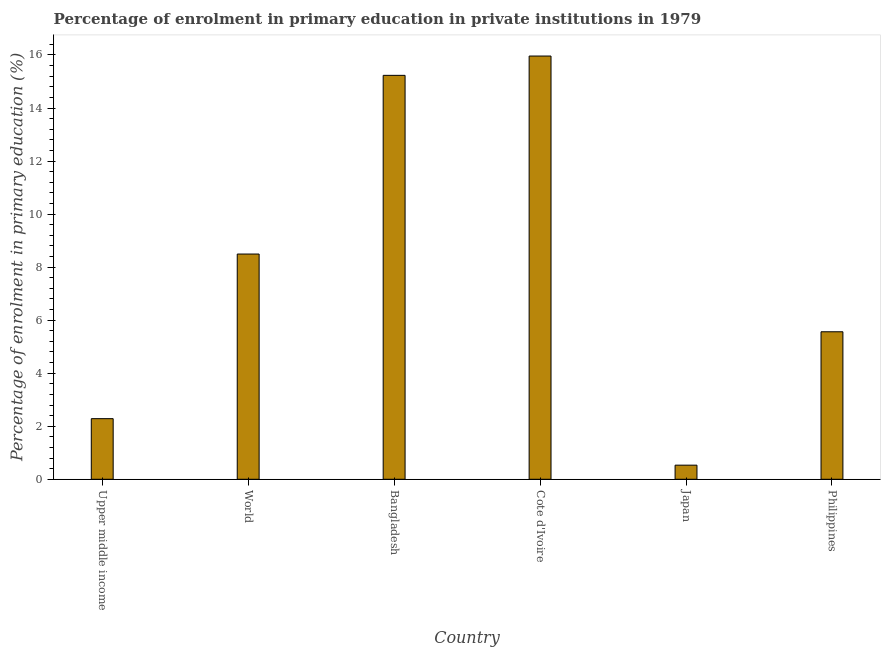Does the graph contain any zero values?
Provide a succinct answer. No. What is the title of the graph?
Give a very brief answer. Percentage of enrolment in primary education in private institutions in 1979. What is the label or title of the X-axis?
Offer a terse response. Country. What is the label or title of the Y-axis?
Provide a succinct answer. Percentage of enrolment in primary education (%). What is the enrolment percentage in primary education in World?
Your answer should be very brief. 8.49. Across all countries, what is the maximum enrolment percentage in primary education?
Provide a short and direct response. 15.96. Across all countries, what is the minimum enrolment percentage in primary education?
Offer a terse response. 0.53. In which country was the enrolment percentage in primary education maximum?
Make the answer very short. Cote d'Ivoire. What is the sum of the enrolment percentage in primary education?
Keep it short and to the point. 48.06. What is the difference between the enrolment percentage in primary education in Upper middle income and World?
Offer a terse response. -6.21. What is the average enrolment percentage in primary education per country?
Offer a very short reply. 8.01. What is the median enrolment percentage in primary education?
Your answer should be very brief. 7.03. In how many countries, is the enrolment percentage in primary education greater than 4 %?
Provide a short and direct response. 4. What is the ratio of the enrolment percentage in primary education in Bangladesh to that in Japan?
Provide a short and direct response. 28.62. Is the difference between the enrolment percentage in primary education in Bangladesh and Upper middle income greater than the difference between any two countries?
Offer a terse response. No. What is the difference between the highest and the second highest enrolment percentage in primary education?
Offer a very short reply. 0.73. Is the sum of the enrolment percentage in primary education in Japan and Upper middle income greater than the maximum enrolment percentage in primary education across all countries?
Offer a very short reply. No. What is the difference between the highest and the lowest enrolment percentage in primary education?
Your answer should be compact. 15.43. How many bars are there?
Give a very brief answer. 6. Are all the bars in the graph horizontal?
Provide a succinct answer. No. What is the difference between two consecutive major ticks on the Y-axis?
Give a very brief answer. 2. What is the Percentage of enrolment in primary education (%) of Upper middle income?
Your answer should be very brief. 2.29. What is the Percentage of enrolment in primary education (%) in World?
Provide a succinct answer. 8.49. What is the Percentage of enrolment in primary education (%) of Bangladesh?
Offer a very short reply. 15.23. What is the Percentage of enrolment in primary education (%) in Cote d'Ivoire?
Your answer should be very brief. 15.96. What is the Percentage of enrolment in primary education (%) of Japan?
Your answer should be compact. 0.53. What is the Percentage of enrolment in primary education (%) in Philippines?
Make the answer very short. 5.56. What is the difference between the Percentage of enrolment in primary education (%) in Upper middle income and World?
Make the answer very short. -6.21. What is the difference between the Percentage of enrolment in primary education (%) in Upper middle income and Bangladesh?
Offer a terse response. -12.95. What is the difference between the Percentage of enrolment in primary education (%) in Upper middle income and Cote d'Ivoire?
Offer a terse response. -13.67. What is the difference between the Percentage of enrolment in primary education (%) in Upper middle income and Japan?
Your response must be concise. 1.75. What is the difference between the Percentage of enrolment in primary education (%) in Upper middle income and Philippines?
Provide a succinct answer. -3.28. What is the difference between the Percentage of enrolment in primary education (%) in World and Bangladesh?
Provide a short and direct response. -6.74. What is the difference between the Percentage of enrolment in primary education (%) in World and Cote d'Ivoire?
Your response must be concise. -7.47. What is the difference between the Percentage of enrolment in primary education (%) in World and Japan?
Provide a short and direct response. 7.96. What is the difference between the Percentage of enrolment in primary education (%) in World and Philippines?
Your answer should be very brief. 2.93. What is the difference between the Percentage of enrolment in primary education (%) in Bangladesh and Cote d'Ivoire?
Your answer should be very brief. -0.73. What is the difference between the Percentage of enrolment in primary education (%) in Bangladesh and Japan?
Give a very brief answer. 14.7. What is the difference between the Percentage of enrolment in primary education (%) in Bangladesh and Philippines?
Your response must be concise. 9.67. What is the difference between the Percentage of enrolment in primary education (%) in Cote d'Ivoire and Japan?
Make the answer very short. 15.43. What is the difference between the Percentage of enrolment in primary education (%) in Cote d'Ivoire and Philippines?
Offer a terse response. 10.4. What is the difference between the Percentage of enrolment in primary education (%) in Japan and Philippines?
Ensure brevity in your answer.  -5.03. What is the ratio of the Percentage of enrolment in primary education (%) in Upper middle income to that in World?
Your answer should be compact. 0.27. What is the ratio of the Percentage of enrolment in primary education (%) in Upper middle income to that in Cote d'Ivoire?
Your response must be concise. 0.14. What is the ratio of the Percentage of enrolment in primary education (%) in Upper middle income to that in Japan?
Your answer should be very brief. 4.29. What is the ratio of the Percentage of enrolment in primary education (%) in Upper middle income to that in Philippines?
Keep it short and to the point. 0.41. What is the ratio of the Percentage of enrolment in primary education (%) in World to that in Bangladesh?
Your answer should be compact. 0.56. What is the ratio of the Percentage of enrolment in primary education (%) in World to that in Cote d'Ivoire?
Make the answer very short. 0.53. What is the ratio of the Percentage of enrolment in primary education (%) in World to that in Japan?
Your answer should be very brief. 15.96. What is the ratio of the Percentage of enrolment in primary education (%) in World to that in Philippines?
Give a very brief answer. 1.53. What is the ratio of the Percentage of enrolment in primary education (%) in Bangladesh to that in Cote d'Ivoire?
Provide a succinct answer. 0.95. What is the ratio of the Percentage of enrolment in primary education (%) in Bangladesh to that in Japan?
Make the answer very short. 28.62. What is the ratio of the Percentage of enrolment in primary education (%) in Bangladesh to that in Philippines?
Provide a short and direct response. 2.74. What is the ratio of the Percentage of enrolment in primary education (%) in Cote d'Ivoire to that in Japan?
Make the answer very short. 29.98. What is the ratio of the Percentage of enrolment in primary education (%) in Cote d'Ivoire to that in Philippines?
Give a very brief answer. 2.87. What is the ratio of the Percentage of enrolment in primary education (%) in Japan to that in Philippines?
Your answer should be very brief. 0.1. 